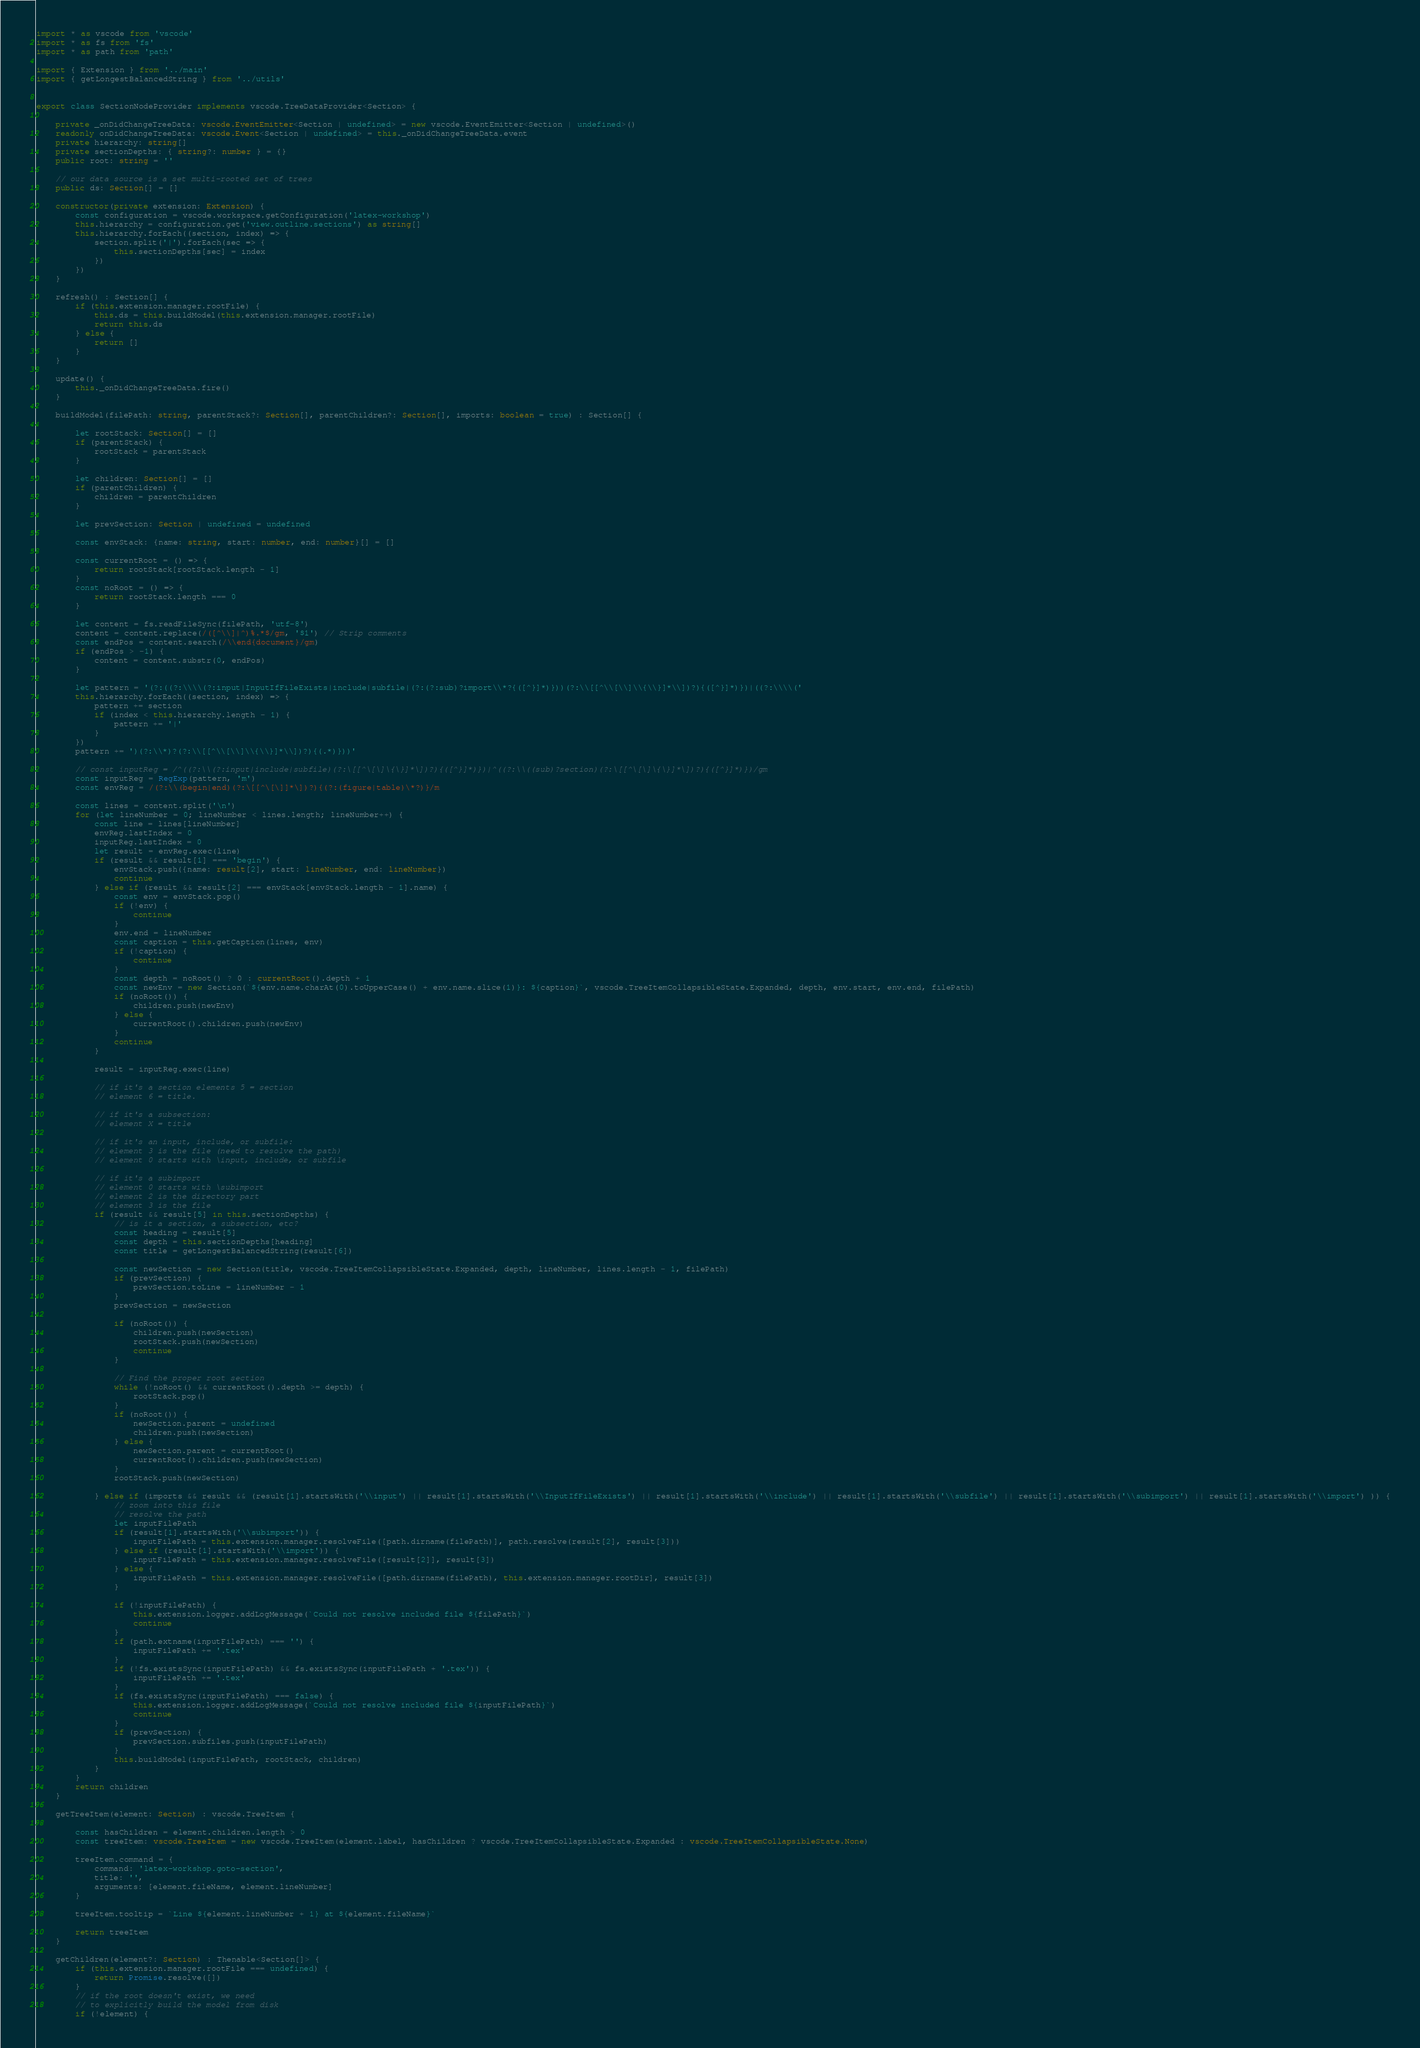<code> <loc_0><loc_0><loc_500><loc_500><_TypeScript_>import * as vscode from 'vscode'
import * as fs from 'fs'
import * as path from 'path'

import { Extension } from '../main'
import { getLongestBalancedString } from '../utils'


export class SectionNodeProvider implements vscode.TreeDataProvider<Section> {

    private _onDidChangeTreeData: vscode.EventEmitter<Section | undefined> = new vscode.EventEmitter<Section | undefined>()
    readonly onDidChangeTreeData: vscode.Event<Section | undefined> = this._onDidChangeTreeData.event
    private hierarchy: string[]
    private sectionDepths: { string?: number } = {}
    public root: string = ''

    // our data source is a set multi-rooted set of trees
    public ds: Section[] = []

    constructor(private extension: Extension) {
        const configuration = vscode.workspace.getConfiguration('latex-workshop')
        this.hierarchy = configuration.get('view.outline.sections') as string[]
        this.hierarchy.forEach((section, index) => {
            section.split('|').forEach(sec => {
                this.sectionDepths[sec] = index
            })
        })
    }

    refresh() : Section[] {
        if (this.extension.manager.rootFile) {
            this.ds = this.buildModel(this.extension.manager.rootFile)
            return this.ds
        } else {
            return []
        }
    }

    update() {
        this._onDidChangeTreeData.fire()
    }

    buildModel(filePath: string, parentStack?: Section[], parentChildren?: Section[], imports: boolean = true) : Section[] {

        let rootStack: Section[] = []
        if (parentStack) {
            rootStack = parentStack
        }

        let children: Section[] = []
        if (parentChildren) {
            children = parentChildren
        }

        let prevSection: Section | undefined = undefined

        const envStack: {name: string, start: number, end: number}[] = []

        const currentRoot = () => {
            return rootStack[rootStack.length - 1]
        }
        const noRoot = () => {
            return rootStack.length === 0
        }

        let content = fs.readFileSync(filePath, 'utf-8')
        content = content.replace(/([^\\]|^)%.*$/gm, '$1') // Strip comments
        const endPos = content.search(/\\end{document}/gm)
        if (endPos > -1) {
            content = content.substr(0, endPos)
        }

        let pattern = '(?:((?:\\\\(?:input|InputIfFileExists|include|subfile|(?:(?:sub)?import\\*?{([^}]*)}))(?:\\[[^\\[\\]\\{\\}]*\\])?){([^}]*)})|((?:\\\\('
        this.hierarchy.forEach((section, index) => {
            pattern += section
            if (index < this.hierarchy.length - 1) {
                pattern += '|'
            }
        })
        pattern += ')(?:\\*)?(?:\\[[^\\[\\]\\{\\}]*\\])?){(.*)}))'

        // const inputReg = /^((?:\\(?:input|include|subfile)(?:\[[^\[\]\{\}]*\])?){([^}]*)})|^((?:\\((sub)?section)(?:\[[^\[\]\{\}]*\])?){([^}]*)})/gm
        const inputReg = RegExp(pattern, 'm')
        const envReg = /(?:\\(begin|end)(?:\[[^\[\]]*\])?){(?:(figure|table)\*?)}/m

        const lines = content.split('\n')
        for (let lineNumber = 0; lineNumber < lines.length; lineNumber++) {
            const line = lines[lineNumber]
            envReg.lastIndex = 0
            inputReg.lastIndex = 0
            let result = envReg.exec(line)
            if (result && result[1] === 'begin') {
                envStack.push({name: result[2], start: lineNumber, end: lineNumber})
                continue
            } else if (result && result[2] === envStack[envStack.length - 1].name) {
                const env = envStack.pop()
                if (!env) {
                    continue
                }
                env.end = lineNumber
                const caption = this.getCaption(lines, env)
                if (!caption) {
                    continue
                }
                const depth = noRoot() ? 0 : currentRoot().depth + 1
                const newEnv = new Section(`${env.name.charAt(0).toUpperCase() + env.name.slice(1)}: ${caption}`, vscode.TreeItemCollapsibleState.Expanded, depth, env.start, env.end, filePath)
                if (noRoot()) {
                    children.push(newEnv)
                } else {
                    currentRoot().children.push(newEnv)
                }
                continue
            }

            result = inputReg.exec(line)

            // if it's a section elements 5 = section
            // element 6 = title.

            // if it's a subsection:
            // element X = title

            // if it's an input, include, or subfile:
            // element 3 is the file (need to resolve the path)
            // element 0 starts with \input, include, or subfile

            // if it's a subimport
            // element 0 starts with \subimport
            // element 2 is the directory part
            // element 3 is the file
            if (result && result[5] in this.sectionDepths) {
                // is it a section, a subsection, etc?
                const heading = result[5]
                const depth = this.sectionDepths[heading]
                const title = getLongestBalancedString(result[6])

                const newSection = new Section(title, vscode.TreeItemCollapsibleState.Expanded, depth, lineNumber, lines.length - 1, filePath)
                if (prevSection) {
                    prevSection.toLine = lineNumber - 1
                }
                prevSection = newSection

                if (noRoot()) {
                    children.push(newSection)
                    rootStack.push(newSection)
                    continue
                }

                // Find the proper root section
                while (!noRoot() && currentRoot().depth >= depth) {
                    rootStack.pop()
                }
                if (noRoot()) {
                    newSection.parent = undefined
                    children.push(newSection)
                } else {
                    newSection.parent = currentRoot()
                    currentRoot().children.push(newSection)
                }
                rootStack.push(newSection)

            } else if (imports && result && (result[1].startsWith('\\input') || result[1].startsWith('\\InputIfFileExists') || result[1].startsWith('\\include') || result[1].startsWith('\\subfile') || result[1].startsWith('\\subimport') || result[1].startsWith('\\import') )) {
                // zoom into this file
                // resolve the path
                let inputFilePath
                if (result[1].startsWith('\\subimport')) {
                    inputFilePath = this.extension.manager.resolveFile([path.dirname(filePath)], path.resolve(result[2], result[3]))
                } else if (result[1].startsWith('\\import')) {
                    inputFilePath = this.extension.manager.resolveFile([result[2]], result[3])
                } else {
                    inputFilePath = this.extension.manager.resolveFile([path.dirname(filePath), this.extension.manager.rootDir], result[3])
                }

                if (!inputFilePath) {
                    this.extension.logger.addLogMessage(`Could not resolve included file ${filePath}`)
                    continue
                }
                if (path.extname(inputFilePath) === '') {
                    inputFilePath += '.tex'
                }
                if (!fs.existsSync(inputFilePath) && fs.existsSync(inputFilePath + '.tex')) {
                    inputFilePath += '.tex'
                }
                if (fs.existsSync(inputFilePath) === false) {
                    this.extension.logger.addLogMessage(`Could not resolve included file ${inputFilePath}`)
                    continue
                }
                if (prevSection) {
                    prevSection.subfiles.push(inputFilePath)
                }
                this.buildModel(inputFilePath, rootStack, children)
            }
        }
        return children
    }

    getTreeItem(element: Section) : vscode.TreeItem {

        const hasChildren = element.children.length > 0
        const treeItem: vscode.TreeItem = new vscode.TreeItem(element.label, hasChildren ? vscode.TreeItemCollapsibleState.Expanded : vscode.TreeItemCollapsibleState.None)

        treeItem.command = {
            command: 'latex-workshop.goto-section',
            title: '',
            arguments: [element.fileName, element.lineNumber]
        }

        treeItem.tooltip = `Line ${element.lineNumber + 1} at ${element.fileName}`

        return treeItem
    }

    getChildren(element?: Section) : Thenable<Section[]> {
        if (this.extension.manager.rootFile === undefined) {
            return Promise.resolve([])
        }
        // if the root doesn't exist, we need
        // to explicitly build the model from disk
        if (!element) {</code> 